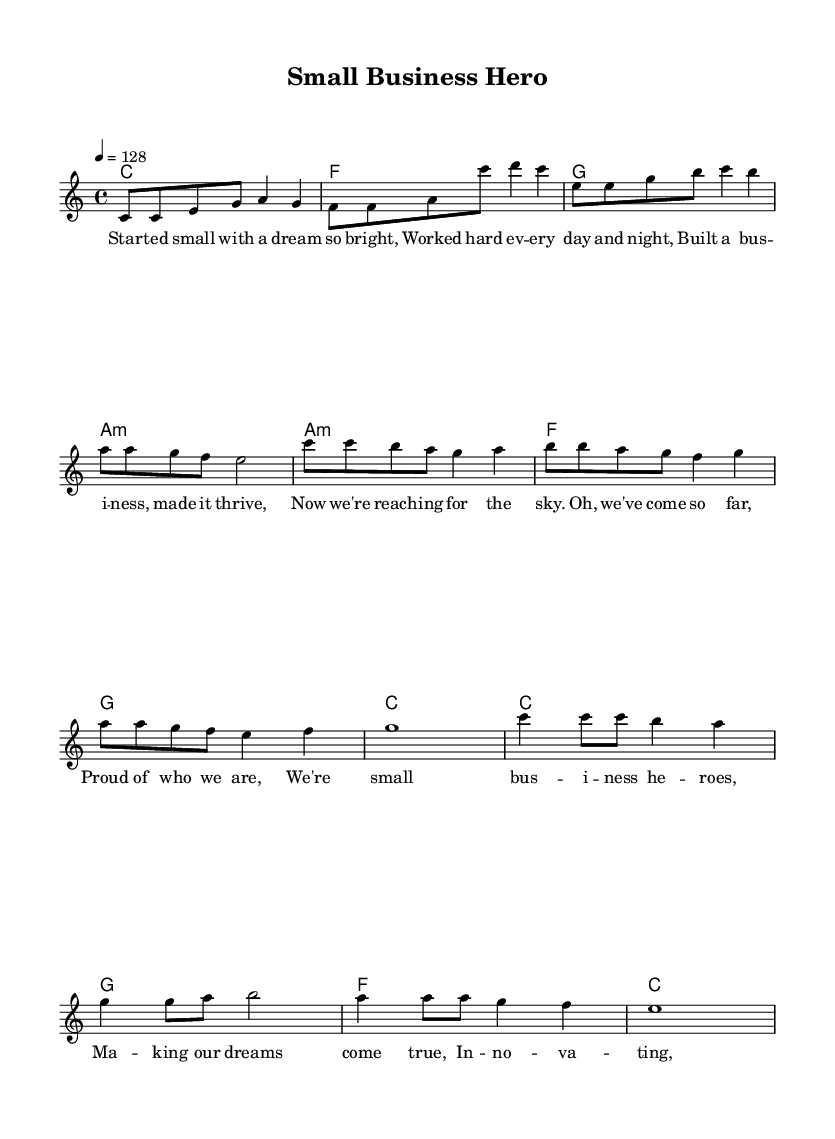What is the key signature of this music? The key signature is C major, which has no sharps or flats.
Answer: C major What is the time signature used in this piece? The time signature is indicated at the beginning of the score, and it shows that there are four beats per measure.
Answer: 4/4 What is the tempo marking for this piece? The tempo marking indicates how fast the music should be played, and in this case, it states a speed of 128 beats per minute.
Answer: 128 Which section follows the verse in the structure of this piece? After examining the given sections, the pre-chorus directly follows the verse, as indicated in the layout of the song.
Answer: Pre-Chorus How many measures are in the chorus? Counting the measures written for the chorus section reveals that there are four measures present in this part of the song.
Answer: 4 What is the theme of the lyrics in this piece? The lyrics celebrate small business success, showcasing determination, growth, and achievement. The overall message is one of empowerment.
Answer: Small business success Which chord follows the A minor chord in the verse section? Looking at the chord progression provided, the A minor chord is followed by a F chord in the verse section.
Answer: F 